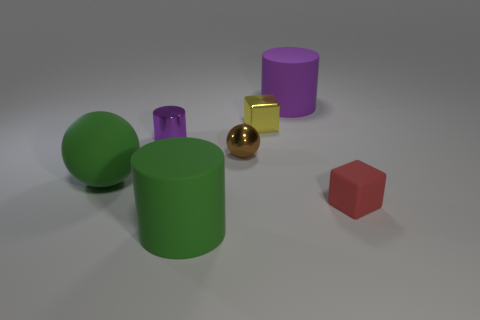Add 1 green balls. How many objects exist? 8 Subtract all balls. How many objects are left? 5 Add 5 big rubber cylinders. How many big rubber cylinders exist? 7 Subtract 0 cyan balls. How many objects are left? 7 Subtract all large purple metallic objects. Subtract all metal cylinders. How many objects are left? 6 Add 5 brown spheres. How many brown spheres are left? 6 